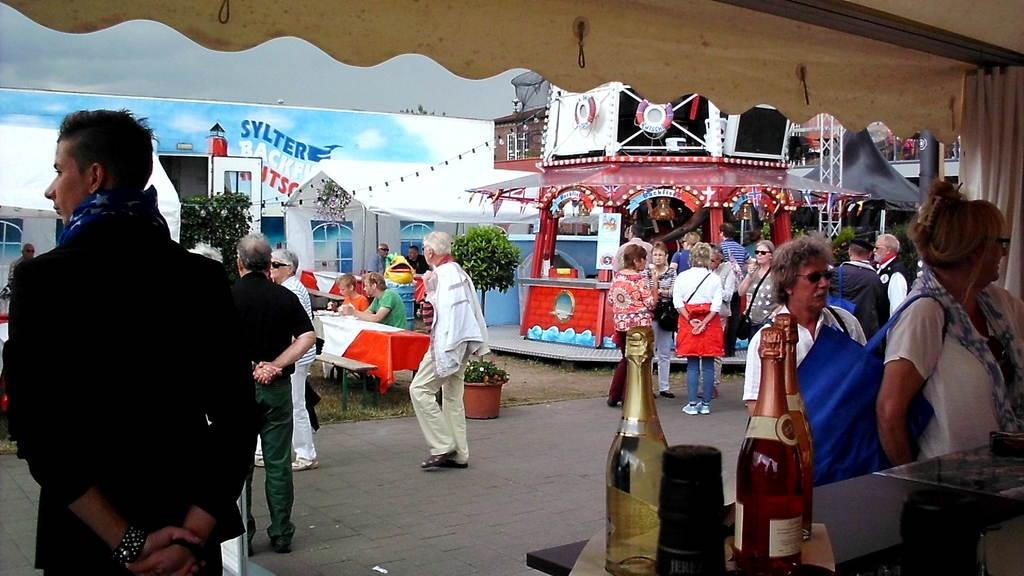What is the gender of the person standing on the left side of the image? There is a man standing on the left side of the image. What can be seen on the right side of the image? There are wine bottles on the right side of the image. What is the woman in the image wearing? The woman is wearing a white dress. What type of pail is being used to make noise in the image? There is no pail or noise present in the image. Can you describe the toothbrush being used by the woman in the image? There is no toothbrush present in the image. 